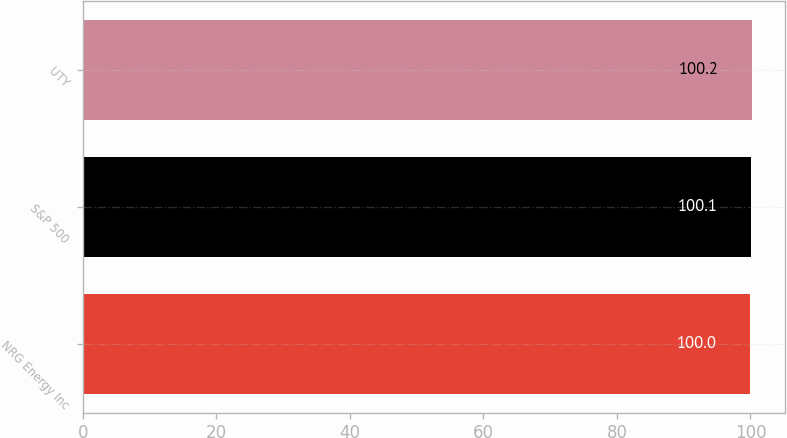Convert chart to OTSL. <chart><loc_0><loc_0><loc_500><loc_500><bar_chart><fcel>NRG Energy Inc<fcel>S&P 500<fcel>UTY<nl><fcel>100<fcel>100.1<fcel>100.2<nl></chart> 